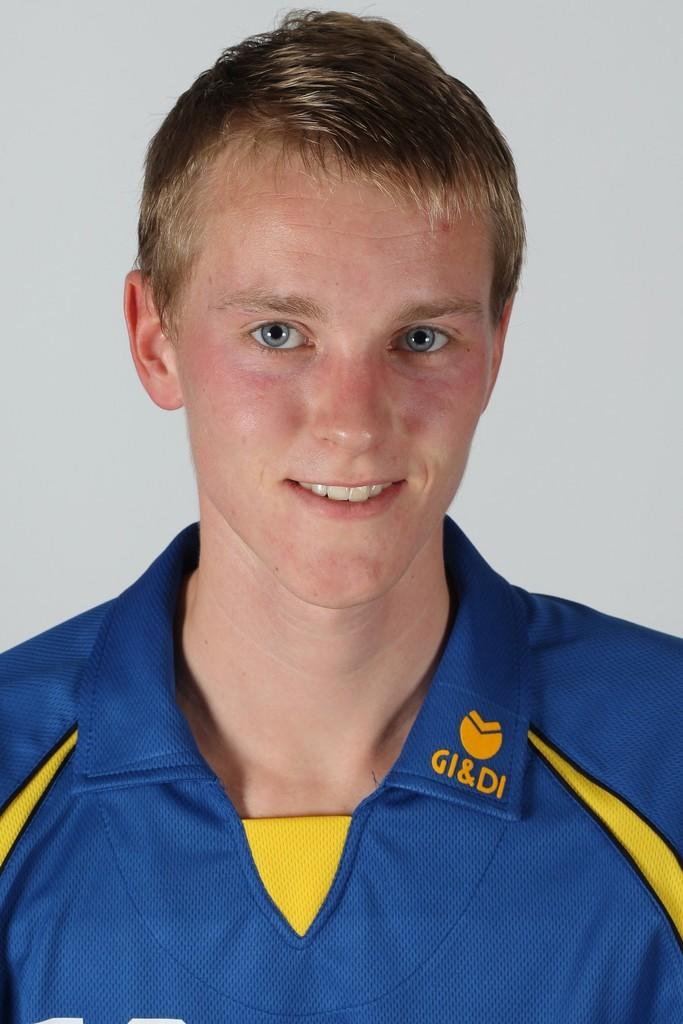<image>
Provide a brief description of the given image. a boy wearin a blue collored shrirt with a gi&di logo 